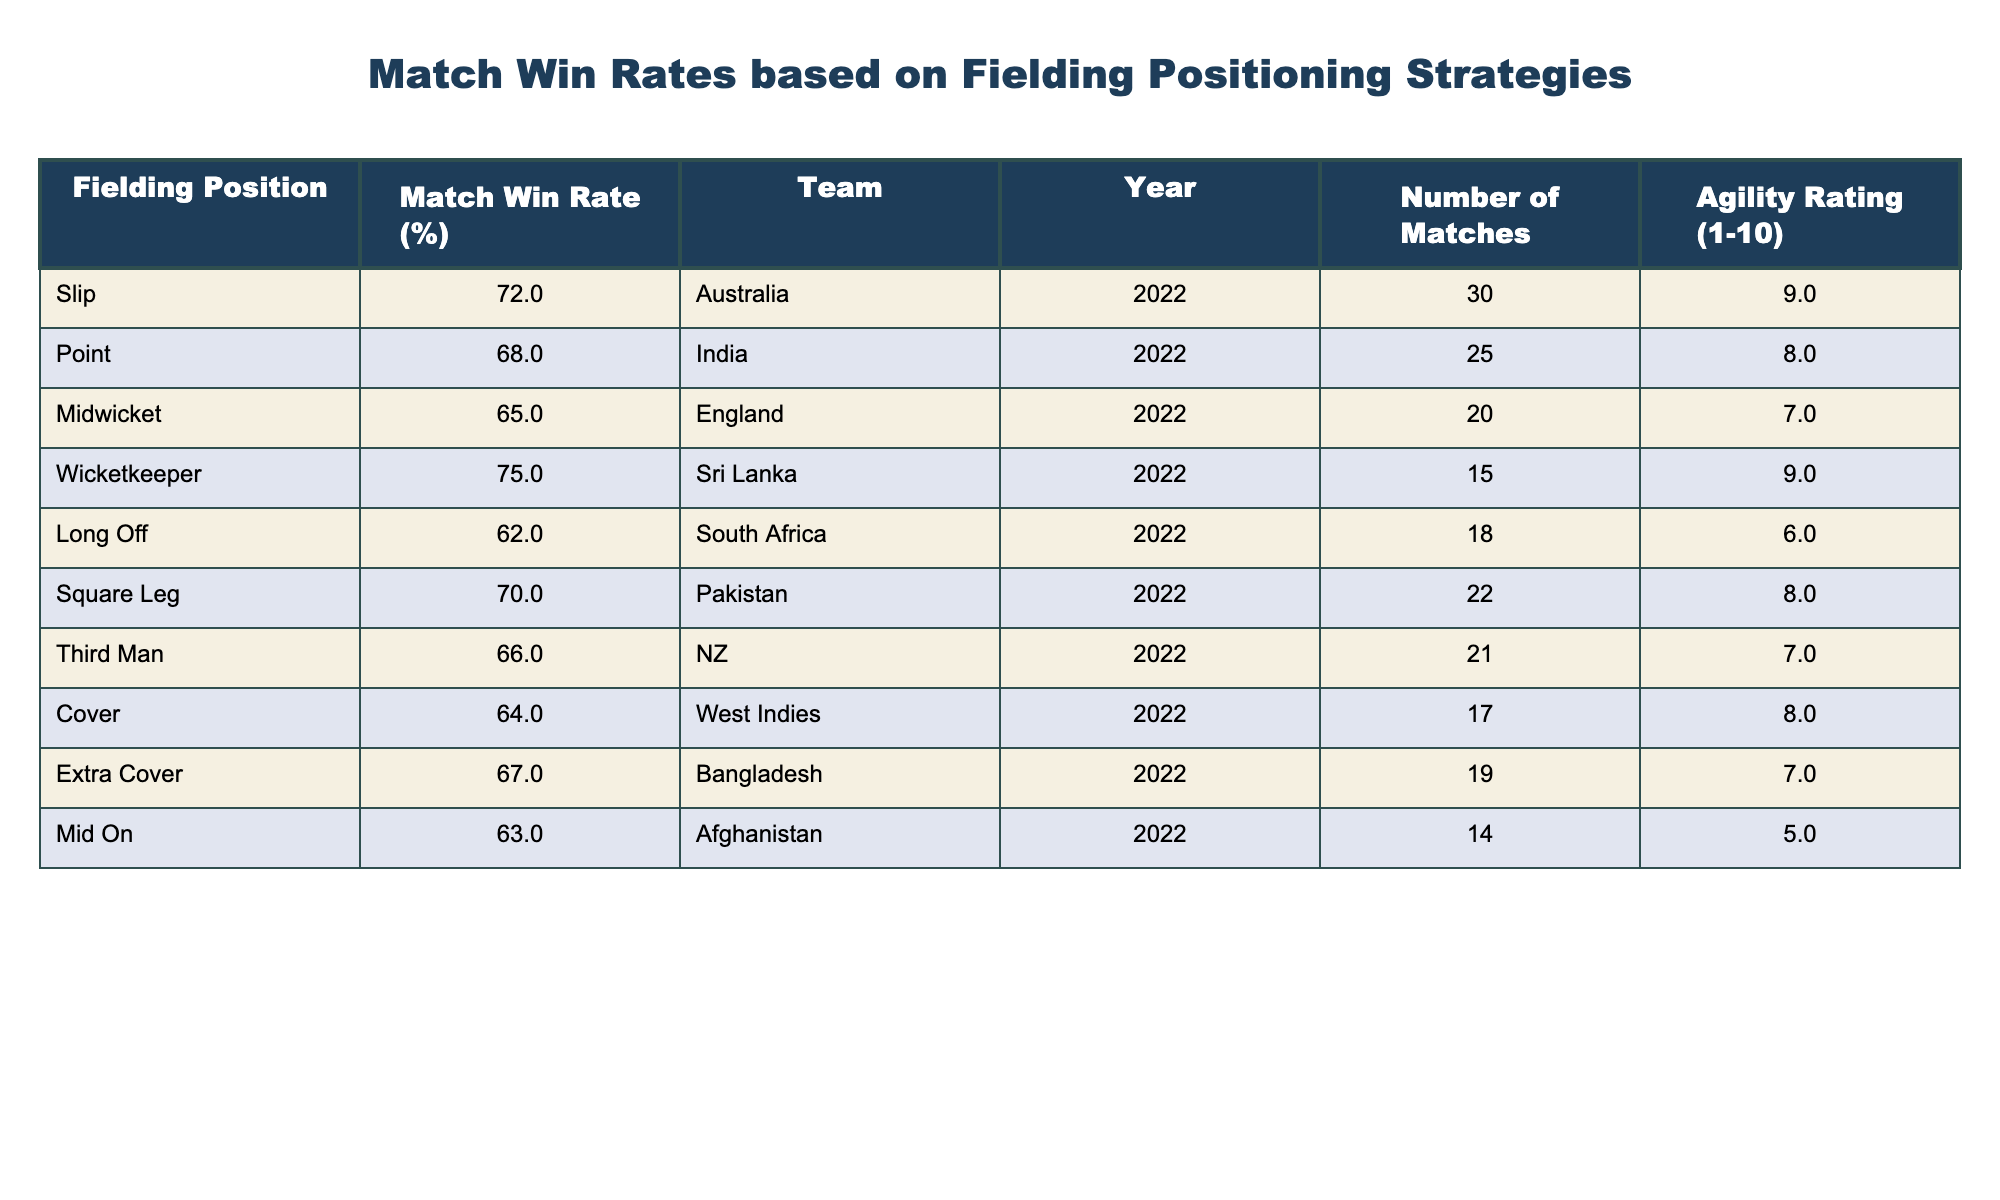What is the match win rate for the Wicketkeeper position? The table shows that the match win rate for the Wicketkeeper position is 75%.
Answer: 75% Which fielding position has the highest agility rating? According to the table, both Slip and Wicketkeeper have the highest agility rating of 9.
Answer: Slip and Wicketkeeper What is the average match win rate across all fielding positions listed? To find the average match win rate, add all the match win rates: (72 + 68 + 65 + 75 + 62 + 70 + 66 + 64 + 67 + 63) = 692. There are 10 positions, so the average is 692 / 10 = 69.2%.
Answer: 69.2% Is the match win rate for Midwicket higher than that for Long Off? The match win rate for Midwicket is 65% while for Long Off, it is 62%. Since 65% is greater than 62%, the statement is true.
Answer: Yes Which team had the lowest match win rate among the listed fielding positions? Looking at the table, South Africa had the lowest match win rate at 62%.
Answer: South Africa What is the difference in match win rate between the team with the highest win rate and the team with the lowest win rate? The highest match win rate is 75% for Wicketkeeper and the lowest is 62% for Long Off. The difference is 75% - 62% = 13%.
Answer: 13% What is the total number of matches played by teams using the Slip position? The table indicates that a total of 30 matches were played by the Slip position.
Answer: 30 Are there any fielding positions with an agility rating of 5 or lower? According to the table, the only position with an agility rating of 5 is Mid On.
Answer: Yes Which fielding position had a match win rate closest to the average win rate? The average win rate is 69.2%. The match win rates that are closest to this value are 70% (Square Leg) and 68% (Point), the closest being Square Leg with a difference of 0.8%.
Answer: Square Leg 